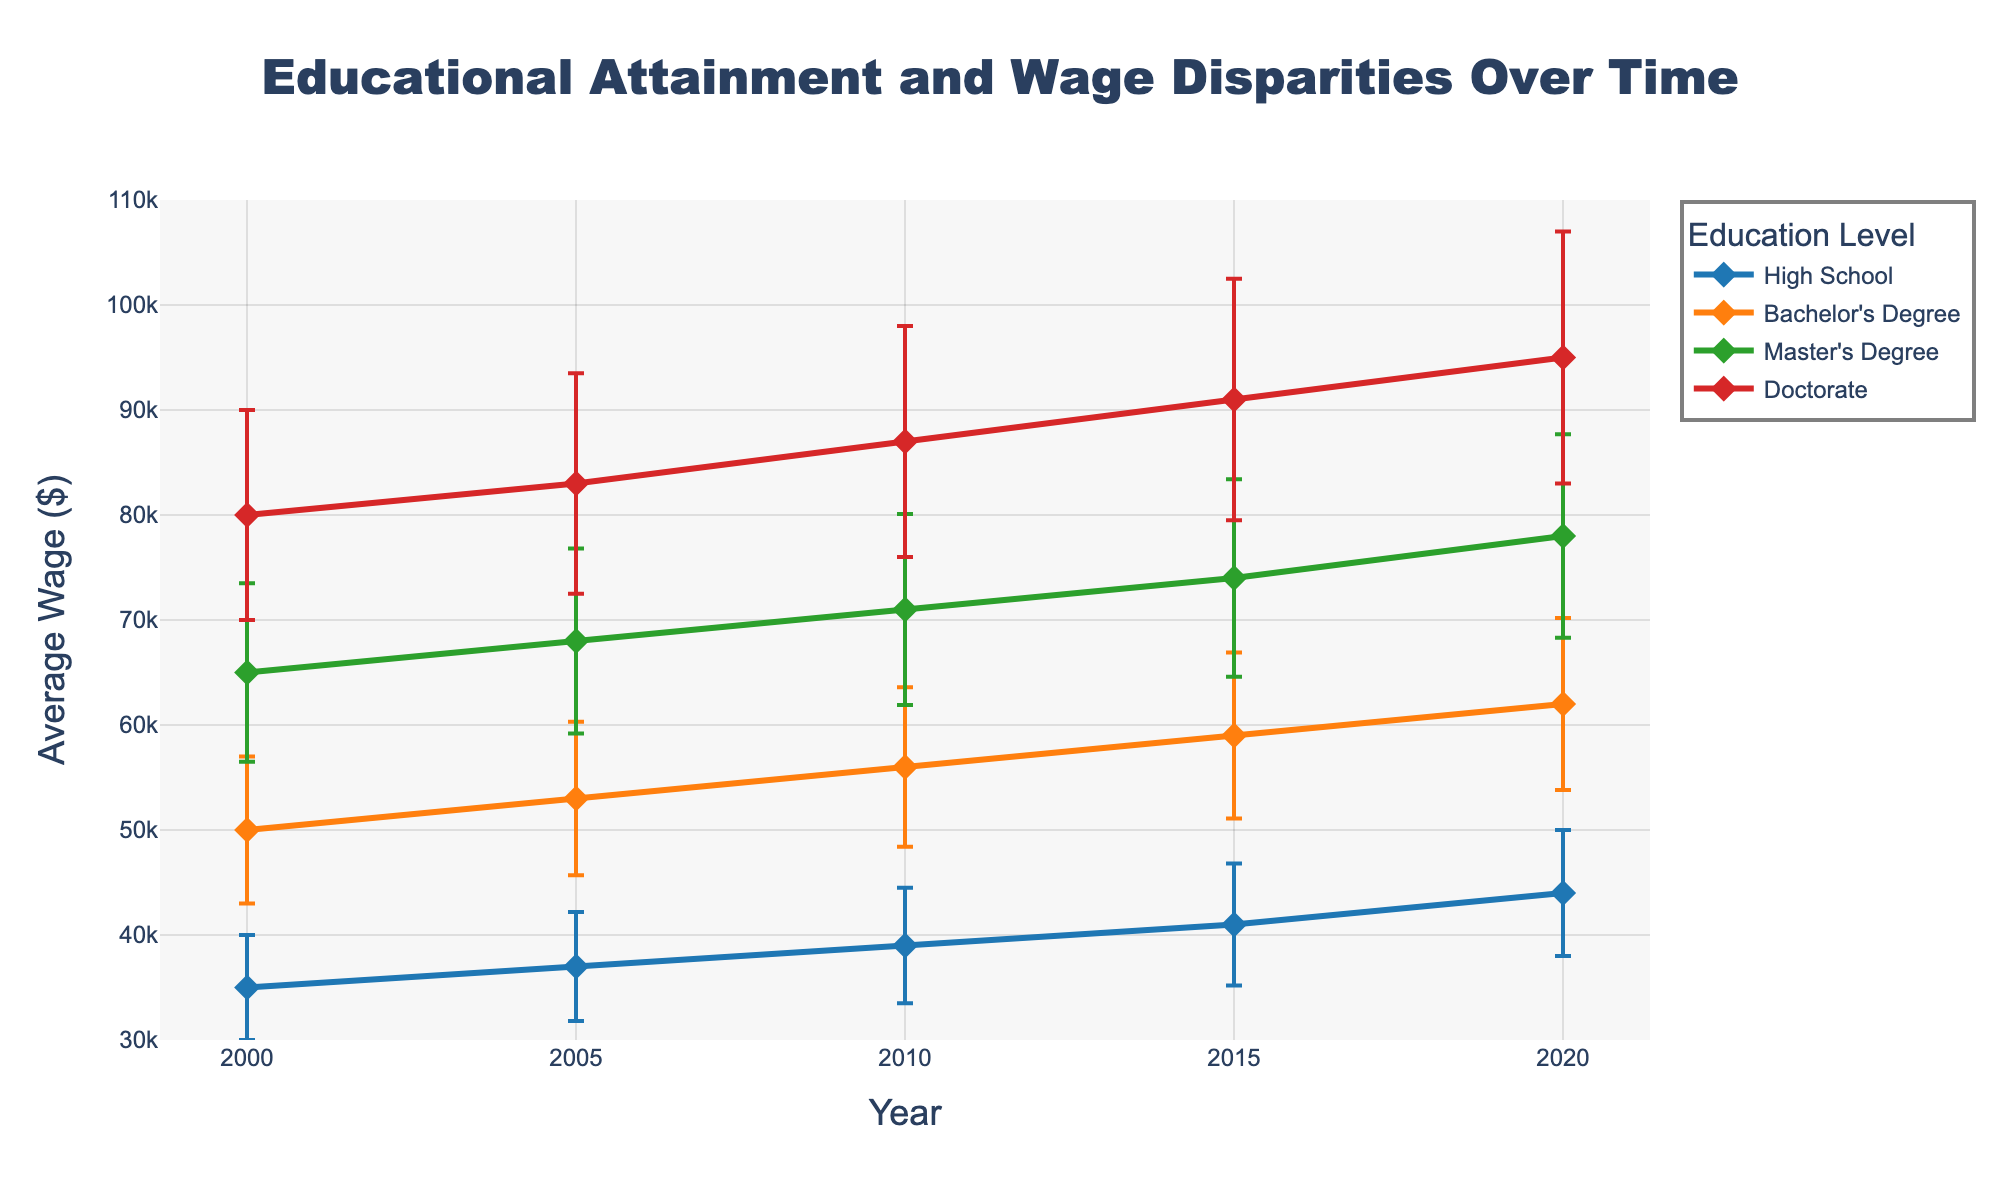What trends do you observe in the average wages of individuals with a High School education over time? The average wage for individuals with a High School education increases over time. It starts at $35,000 in 2000 and rises steadily up to $44,000 in 2020.
Answer: Increasing trend Which education level experiences the highest wage in 2020? By comparing the average wages for different education levels in 2020, the highest wage is for individuals with a Doctorate at $95,000.
Answer: Doctorate How does the wage discrepancy between Bachelor's Degree and Master's Degree compare in 2015? In 2015, the average wage for a Bachelor’s Degree is $59,000 and for a Master’s Degree is $74,000. The discrepancy is calculated as $74,000 - $59,000 = $15,000.
Answer: $15,000 Which education level has the greatest increase in average wage from 2000 to 2020? Comparing the differences in average wages from 2000 to 2020, the increase for High School is $9,000, for Bachelor’s Degree is $12,000, for Master’s Degree is $13,000, and for Doctorate is $15,000. Thus, Doctorate has the greatest increase.
Answer: Doctorate In 2010, which education level has the largest standard deviation in wages? The largest standard deviation in 2010 is observed for Doctorate which has a standard deviation of $11,000.
Answer: Doctorate What is the average wage for individuals with a Master's Degree in 2005 and its standard deviation? The average wage for individuals with a Master's Degree in 2005 is $68,000 and the standard deviation is $8,800.
Answer: $68,000 and $8,800 Are there any years where the wages of individuals with a Bachelor's Degree and a Doctorate do not follow the expected increasing trend? No, the wages for both Bachelor’s Degree and Doctorate consistently increase year by year from 2000 to 2020.
Answer: No deviations What is the wage difference between individuals with a Doctorate and those with a Bachelor's Degree in 2000? In 2000, the average wage for a Doctorate is $80,000 and for a Bachelor’s Degree is $50,000. The difference is $80,000 - $50,000 = $30,000.
Answer: $30,000 How does the range of wages (considering standard deviations) for High School level change from 2000 to 2020? In 2000, the range is $35,000 ± $5,000, resulting in [30,000, 40,000]. In 2020, it is $44,000 ± $6,000, giving [38,000, 50,000]. The range increases from 10,000 to 12,000.
Answer: Increases to 12,000 What are the implications of wage disparities based on educational attainments in terms of socioeconomic inequalities? Wage disparities based on educational attainment suggest that individuals with higher levels of education tend to earn significantly more, potentially widening socioeconomic inequalities as the gap between income levels of various educational groups increases over time.
Answer: Widening socioeconomic inequalities 